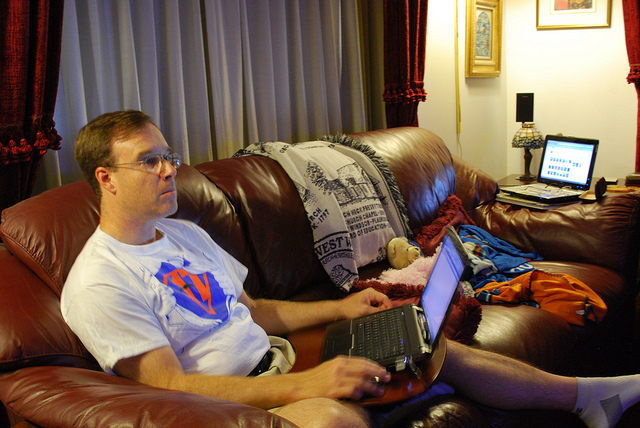<image>Is this man watching TV? It is ambiguous if the man is watching TV. Is this man watching TV? I don't know if the man is watching TV. It can be both yes and no. 